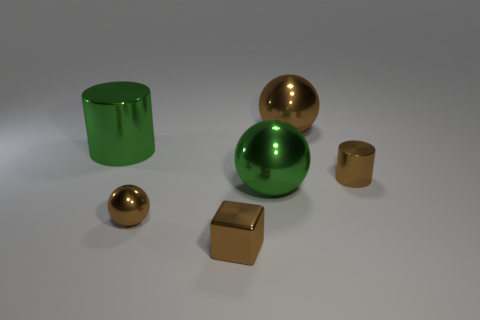Add 3 tiny metal cylinders. How many objects exist? 9 Subtract all big spheres. How many spheres are left? 1 Subtract all gray cylinders. How many brown spheres are left? 2 Subtract all brown cylinders. How many cylinders are left? 1 Subtract all blue metallic things. Subtract all brown balls. How many objects are left? 4 Add 3 brown metallic things. How many brown metallic things are left? 7 Add 5 large green shiny things. How many large green shiny things exist? 7 Subtract 0 gray cylinders. How many objects are left? 6 Subtract all cylinders. How many objects are left? 4 Subtract 1 balls. How many balls are left? 2 